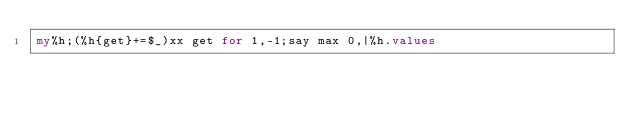<code> <loc_0><loc_0><loc_500><loc_500><_Perl_>my%h;(%h{get}+=$_)xx get for 1,-1;say max 0,|%h.values</code> 